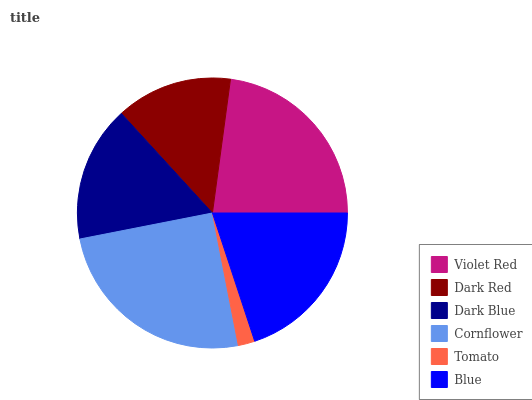Is Tomato the minimum?
Answer yes or no. Yes. Is Cornflower the maximum?
Answer yes or no. Yes. Is Dark Red the minimum?
Answer yes or no. No. Is Dark Red the maximum?
Answer yes or no. No. Is Violet Red greater than Dark Red?
Answer yes or no. Yes. Is Dark Red less than Violet Red?
Answer yes or no. Yes. Is Dark Red greater than Violet Red?
Answer yes or no. No. Is Violet Red less than Dark Red?
Answer yes or no. No. Is Blue the high median?
Answer yes or no. Yes. Is Dark Blue the low median?
Answer yes or no. Yes. Is Cornflower the high median?
Answer yes or no. No. Is Dark Red the low median?
Answer yes or no. No. 